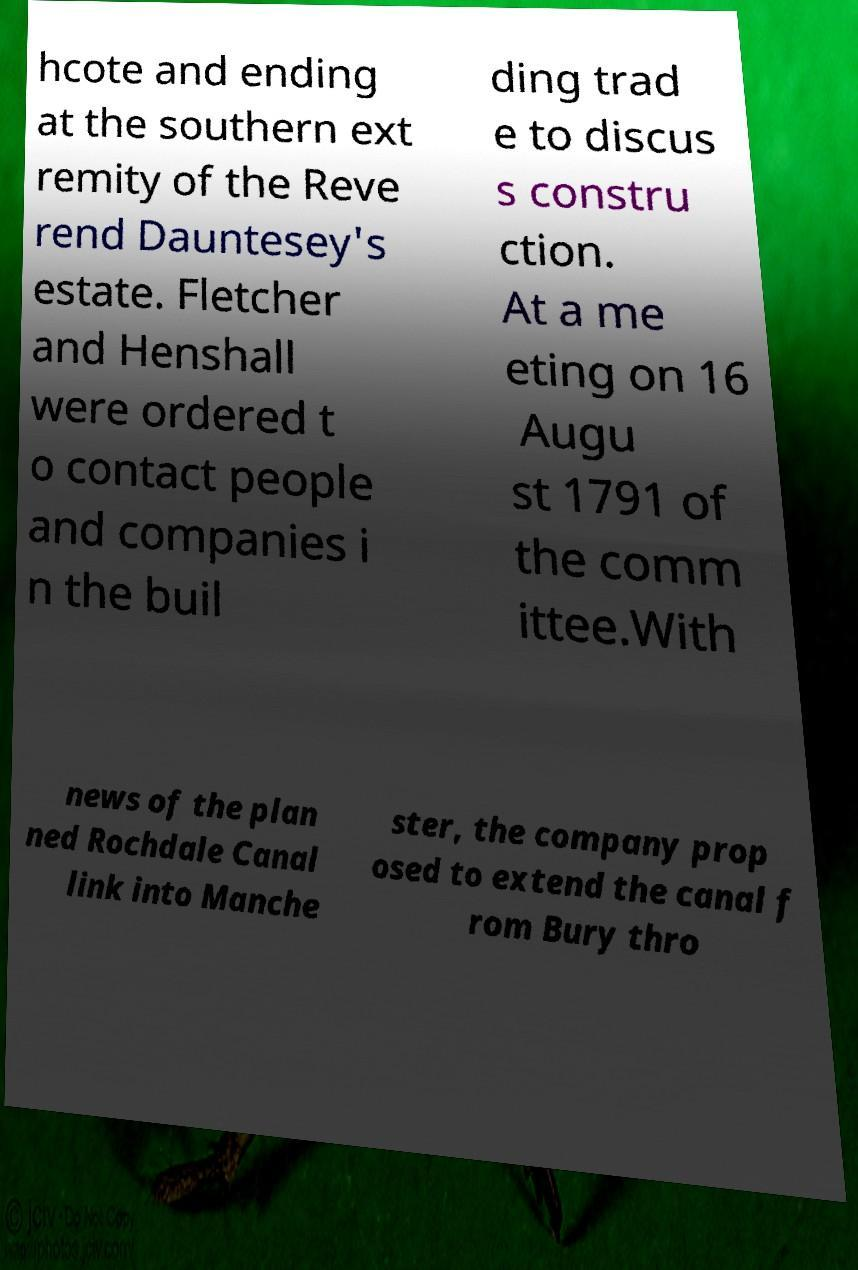For documentation purposes, I need the text within this image transcribed. Could you provide that? hcote and ending at the southern ext remity of the Reve rend Dauntesey's estate. Fletcher and Henshall were ordered t o contact people and companies i n the buil ding trad e to discus s constru ction. At a me eting on 16 Augu st 1791 of the comm ittee.With news of the plan ned Rochdale Canal link into Manche ster, the company prop osed to extend the canal f rom Bury thro 